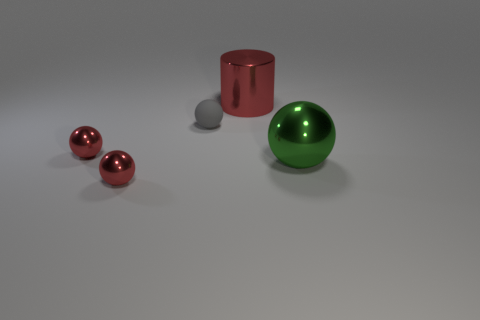Are there the same number of tiny red things behind the big metal cylinder and balls in front of the small gray thing?
Offer a very short reply. No. What material is the tiny red thing behind the ball in front of the large green sphere?
Offer a terse response. Metal. How many things are either tiny matte balls or large cylinders?
Keep it short and to the point. 2. Are there fewer large things than big red metallic cylinders?
Make the answer very short. No. What size is the green ball that is the same material as the red cylinder?
Give a very brief answer. Large. What size is the gray matte thing?
Your answer should be very brief. Small. The small gray matte object has what shape?
Your response must be concise. Sphere. There is a big shiny object that is in front of the gray matte thing; does it have the same color as the tiny matte thing?
Offer a very short reply. No. What is the size of the gray matte object that is the same shape as the big green metal object?
Your answer should be very brief. Small. Is there any other thing that is made of the same material as the big sphere?
Ensure brevity in your answer.  Yes. 